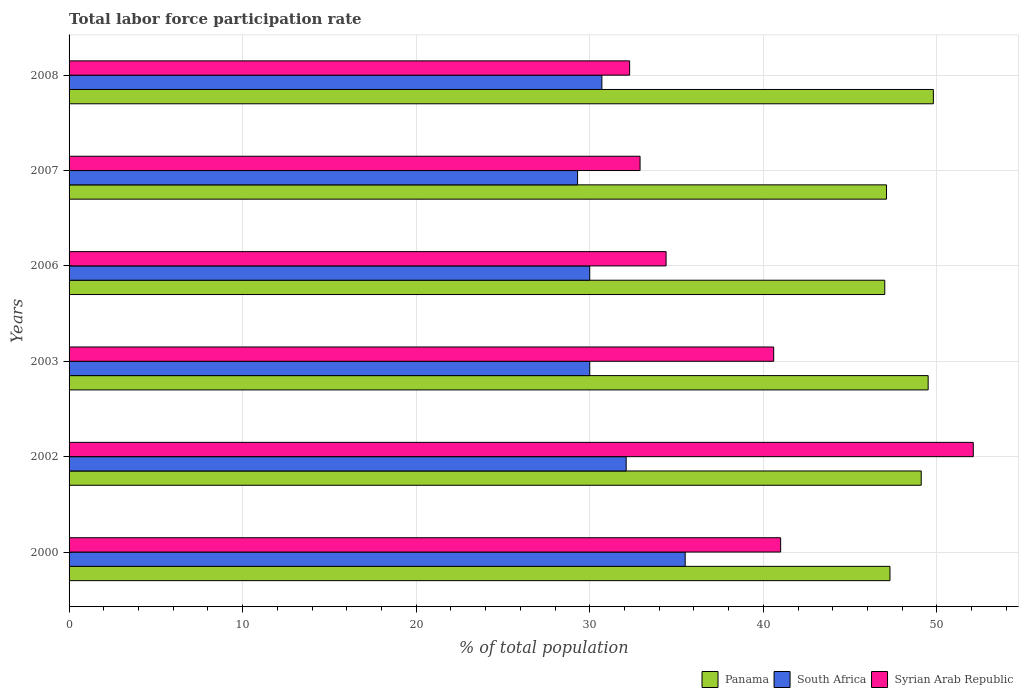How many groups of bars are there?
Keep it short and to the point. 6. Are the number of bars per tick equal to the number of legend labels?
Your answer should be compact. Yes. Are the number of bars on each tick of the Y-axis equal?
Make the answer very short. Yes. How many bars are there on the 2nd tick from the top?
Provide a short and direct response. 3. What is the label of the 3rd group of bars from the top?
Ensure brevity in your answer.  2006. In how many cases, is the number of bars for a given year not equal to the number of legend labels?
Offer a terse response. 0. What is the total labor force participation rate in Syrian Arab Republic in 2003?
Offer a terse response. 40.6. Across all years, what is the maximum total labor force participation rate in South Africa?
Ensure brevity in your answer.  35.5. In which year was the total labor force participation rate in Syrian Arab Republic maximum?
Your answer should be compact. 2002. What is the total total labor force participation rate in South Africa in the graph?
Your answer should be very brief. 187.6. What is the difference between the total labor force participation rate in Panama in 2000 and that in 2007?
Your response must be concise. 0.2. What is the difference between the total labor force participation rate in South Africa in 2008 and the total labor force participation rate in Syrian Arab Republic in 2002?
Your answer should be compact. -21.4. What is the average total labor force participation rate in Syrian Arab Republic per year?
Give a very brief answer. 38.88. In the year 2006, what is the difference between the total labor force participation rate in Syrian Arab Republic and total labor force participation rate in Panama?
Make the answer very short. -12.6. What is the ratio of the total labor force participation rate in South Africa in 2007 to that in 2008?
Your answer should be very brief. 0.95. Is the total labor force participation rate in South Africa in 2006 less than that in 2007?
Your response must be concise. No. Is the difference between the total labor force participation rate in Syrian Arab Republic in 2007 and 2008 greater than the difference between the total labor force participation rate in Panama in 2007 and 2008?
Keep it short and to the point. Yes. What is the difference between the highest and the second highest total labor force participation rate in Syrian Arab Republic?
Your response must be concise. 11.1. What is the difference between the highest and the lowest total labor force participation rate in South Africa?
Provide a succinct answer. 6.2. In how many years, is the total labor force participation rate in Panama greater than the average total labor force participation rate in Panama taken over all years?
Keep it short and to the point. 3. What does the 3rd bar from the top in 2006 represents?
Offer a terse response. Panama. What does the 3rd bar from the bottom in 2008 represents?
Make the answer very short. Syrian Arab Republic. Is it the case that in every year, the sum of the total labor force participation rate in Panama and total labor force participation rate in Syrian Arab Republic is greater than the total labor force participation rate in South Africa?
Keep it short and to the point. Yes. How many bars are there?
Make the answer very short. 18. How many years are there in the graph?
Your response must be concise. 6. What is the difference between two consecutive major ticks on the X-axis?
Ensure brevity in your answer.  10. Are the values on the major ticks of X-axis written in scientific E-notation?
Give a very brief answer. No. Does the graph contain any zero values?
Keep it short and to the point. No. Does the graph contain grids?
Your response must be concise. Yes. Where does the legend appear in the graph?
Provide a succinct answer. Bottom right. How are the legend labels stacked?
Make the answer very short. Horizontal. What is the title of the graph?
Keep it short and to the point. Total labor force participation rate. Does "St. Martin (French part)" appear as one of the legend labels in the graph?
Give a very brief answer. No. What is the label or title of the X-axis?
Offer a very short reply. % of total population. What is the label or title of the Y-axis?
Make the answer very short. Years. What is the % of total population in Panama in 2000?
Offer a terse response. 47.3. What is the % of total population of South Africa in 2000?
Your answer should be very brief. 35.5. What is the % of total population of Syrian Arab Republic in 2000?
Offer a terse response. 41. What is the % of total population of Panama in 2002?
Make the answer very short. 49.1. What is the % of total population in South Africa in 2002?
Offer a terse response. 32.1. What is the % of total population of Syrian Arab Republic in 2002?
Give a very brief answer. 52.1. What is the % of total population in Panama in 2003?
Keep it short and to the point. 49.5. What is the % of total population of Syrian Arab Republic in 2003?
Give a very brief answer. 40.6. What is the % of total population in Panama in 2006?
Your answer should be compact. 47. What is the % of total population in Syrian Arab Republic in 2006?
Your answer should be very brief. 34.4. What is the % of total population in Panama in 2007?
Your answer should be compact. 47.1. What is the % of total population in South Africa in 2007?
Your answer should be compact. 29.3. What is the % of total population of Syrian Arab Republic in 2007?
Provide a short and direct response. 32.9. What is the % of total population in Panama in 2008?
Provide a succinct answer. 49.8. What is the % of total population in South Africa in 2008?
Make the answer very short. 30.7. What is the % of total population of Syrian Arab Republic in 2008?
Make the answer very short. 32.3. Across all years, what is the maximum % of total population in Panama?
Give a very brief answer. 49.8. Across all years, what is the maximum % of total population in South Africa?
Your response must be concise. 35.5. Across all years, what is the maximum % of total population of Syrian Arab Republic?
Your response must be concise. 52.1. Across all years, what is the minimum % of total population of South Africa?
Give a very brief answer. 29.3. Across all years, what is the minimum % of total population in Syrian Arab Republic?
Provide a succinct answer. 32.3. What is the total % of total population of Panama in the graph?
Give a very brief answer. 289.8. What is the total % of total population in South Africa in the graph?
Offer a terse response. 187.6. What is the total % of total population of Syrian Arab Republic in the graph?
Keep it short and to the point. 233.3. What is the difference between the % of total population in Panama in 2000 and that in 2002?
Ensure brevity in your answer.  -1.8. What is the difference between the % of total population in South Africa in 2000 and that in 2002?
Provide a short and direct response. 3.4. What is the difference between the % of total population in Syrian Arab Republic in 2000 and that in 2002?
Keep it short and to the point. -11.1. What is the difference between the % of total population of South Africa in 2000 and that in 2003?
Keep it short and to the point. 5.5. What is the difference between the % of total population of Syrian Arab Republic in 2000 and that in 2003?
Ensure brevity in your answer.  0.4. What is the difference between the % of total population in Panama in 2000 and that in 2006?
Ensure brevity in your answer.  0.3. What is the difference between the % of total population in South Africa in 2000 and that in 2006?
Offer a very short reply. 5.5. What is the difference between the % of total population of Syrian Arab Republic in 2000 and that in 2006?
Your response must be concise. 6.6. What is the difference between the % of total population of Panama in 2000 and that in 2007?
Keep it short and to the point. 0.2. What is the difference between the % of total population of South Africa in 2000 and that in 2007?
Make the answer very short. 6.2. What is the difference between the % of total population of Syrian Arab Republic in 2002 and that in 2003?
Provide a short and direct response. 11.5. What is the difference between the % of total population of Panama in 2002 and that in 2006?
Keep it short and to the point. 2.1. What is the difference between the % of total population in South Africa in 2002 and that in 2006?
Ensure brevity in your answer.  2.1. What is the difference between the % of total population of South Africa in 2002 and that in 2007?
Make the answer very short. 2.8. What is the difference between the % of total population of Panama in 2002 and that in 2008?
Make the answer very short. -0.7. What is the difference between the % of total population of Syrian Arab Republic in 2002 and that in 2008?
Your response must be concise. 19.8. What is the difference between the % of total population of Panama in 2003 and that in 2006?
Offer a terse response. 2.5. What is the difference between the % of total population in Syrian Arab Republic in 2003 and that in 2007?
Ensure brevity in your answer.  7.7. What is the difference between the % of total population of Panama in 2006 and that in 2007?
Make the answer very short. -0.1. What is the difference between the % of total population in South Africa in 2006 and that in 2007?
Your response must be concise. 0.7. What is the difference between the % of total population in Syrian Arab Republic in 2006 and that in 2007?
Your answer should be very brief. 1.5. What is the difference between the % of total population in Panama in 2006 and that in 2008?
Give a very brief answer. -2.8. What is the difference between the % of total population in Syrian Arab Republic in 2006 and that in 2008?
Ensure brevity in your answer.  2.1. What is the difference between the % of total population of South Africa in 2007 and that in 2008?
Your response must be concise. -1.4. What is the difference between the % of total population in Syrian Arab Republic in 2007 and that in 2008?
Give a very brief answer. 0.6. What is the difference between the % of total population in Panama in 2000 and the % of total population in South Africa in 2002?
Your response must be concise. 15.2. What is the difference between the % of total population in South Africa in 2000 and the % of total population in Syrian Arab Republic in 2002?
Your response must be concise. -16.6. What is the difference between the % of total population of South Africa in 2000 and the % of total population of Syrian Arab Republic in 2003?
Your answer should be very brief. -5.1. What is the difference between the % of total population in Panama in 2000 and the % of total population in South Africa in 2006?
Your answer should be compact. 17.3. What is the difference between the % of total population in Panama in 2000 and the % of total population in Syrian Arab Republic in 2007?
Your response must be concise. 14.4. What is the difference between the % of total population of Panama in 2000 and the % of total population of South Africa in 2008?
Make the answer very short. 16.6. What is the difference between the % of total population of Panama in 2000 and the % of total population of Syrian Arab Republic in 2008?
Provide a short and direct response. 15. What is the difference between the % of total population of South Africa in 2002 and the % of total population of Syrian Arab Republic in 2003?
Offer a terse response. -8.5. What is the difference between the % of total population in Panama in 2002 and the % of total population in Syrian Arab Republic in 2006?
Ensure brevity in your answer.  14.7. What is the difference between the % of total population of Panama in 2002 and the % of total population of South Africa in 2007?
Your answer should be compact. 19.8. What is the difference between the % of total population of Panama in 2002 and the % of total population of Syrian Arab Republic in 2007?
Make the answer very short. 16.2. What is the difference between the % of total population in South Africa in 2002 and the % of total population in Syrian Arab Republic in 2007?
Offer a very short reply. -0.8. What is the difference between the % of total population in Panama in 2002 and the % of total population in South Africa in 2008?
Your answer should be compact. 18.4. What is the difference between the % of total population in Panama in 2002 and the % of total population in Syrian Arab Republic in 2008?
Provide a succinct answer. 16.8. What is the difference between the % of total population of Panama in 2003 and the % of total population of Syrian Arab Republic in 2006?
Your response must be concise. 15.1. What is the difference between the % of total population in South Africa in 2003 and the % of total population in Syrian Arab Republic in 2006?
Provide a succinct answer. -4.4. What is the difference between the % of total population of Panama in 2003 and the % of total population of South Africa in 2007?
Keep it short and to the point. 20.2. What is the difference between the % of total population of Panama in 2003 and the % of total population of Syrian Arab Republic in 2007?
Offer a terse response. 16.6. What is the difference between the % of total population of Panama in 2003 and the % of total population of Syrian Arab Republic in 2008?
Make the answer very short. 17.2. What is the difference between the % of total population in South Africa in 2003 and the % of total population in Syrian Arab Republic in 2008?
Provide a succinct answer. -2.3. What is the difference between the % of total population of Panama in 2006 and the % of total population of Syrian Arab Republic in 2007?
Offer a terse response. 14.1. What is the difference between the % of total population in South Africa in 2006 and the % of total population in Syrian Arab Republic in 2007?
Offer a terse response. -2.9. What is the difference between the % of total population of Panama in 2006 and the % of total population of South Africa in 2008?
Keep it short and to the point. 16.3. What is the difference between the % of total population in Panama in 2006 and the % of total population in Syrian Arab Republic in 2008?
Provide a short and direct response. 14.7. What is the difference between the % of total population in South Africa in 2006 and the % of total population in Syrian Arab Republic in 2008?
Keep it short and to the point. -2.3. What is the difference between the % of total population of Panama in 2007 and the % of total population of Syrian Arab Republic in 2008?
Your answer should be compact. 14.8. What is the average % of total population of Panama per year?
Your answer should be very brief. 48.3. What is the average % of total population of South Africa per year?
Your answer should be very brief. 31.27. What is the average % of total population in Syrian Arab Republic per year?
Provide a short and direct response. 38.88. In the year 2000, what is the difference between the % of total population of Panama and % of total population of South Africa?
Offer a terse response. 11.8. In the year 2000, what is the difference between the % of total population of Panama and % of total population of Syrian Arab Republic?
Your response must be concise. 6.3. In the year 2003, what is the difference between the % of total population of Panama and % of total population of South Africa?
Provide a succinct answer. 19.5. In the year 2006, what is the difference between the % of total population of Panama and % of total population of South Africa?
Give a very brief answer. 17. In the year 2006, what is the difference between the % of total population of Panama and % of total population of Syrian Arab Republic?
Offer a very short reply. 12.6. In the year 2006, what is the difference between the % of total population of South Africa and % of total population of Syrian Arab Republic?
Ensure brevity in your answer.  -4.4. In the year 2007, what is the difference between the % of total population in South Africa and % of total population in Syrian Arab Republic?
Offer a terse response. -3.6. In the year 2008, what is the difference between the % of total population in Panama and % of total population in South Africa?
Ensure brevity in your answer.  19.1. What is the ratio of the % of total population in Panama in 2000 to that in 2002?
Provide a succinct answer. 0.96. What is the ratio of the % of total population in South Africa in 2000 to that in 2002?
Provide a succinct answer. 1.11. What is the ratio of the % of total population in Syrian Arab Republic in 2000 to that in 2002?
Offer a terse response. 0.79. What is the ratio of the % of total population in Panama in 2000 to that in 2003?
Your response must be concise. 0.96. What is the ratio of the % of total population of South Africa in 2000 to that in 2003?
Offer a terse response. 1.18. What is the ratio of the % of total population in Syrian Arab Republic in 2000 to that in 2003?
Your response must be concise. 1.01. What is the ratio of the % of total population of Panama in 2000 to that in 2006?
Provide a succinct answer. 1.01. What is the ratio of the % of total population of South Africa in 2000 to that in 2006?
Ensure brevity in your answer.  1.18. What is the ratio of the % of total population in Syrian Arab Republic in 2000 to that in 2006?
Make the answer very short. 1.19. What is the ratio of the % of total population in Panama in 2000 to that in 2007?
Keep it short and to the point. 1. What is the ratio of the % of total population of South Africa in 2000 to that in 2007?
Your response must be concise. 1.21. What is the ratio of the % of total population of Syrian Arab Republic in 2000 to that in 2007?
Offer a very short reply. 1.25. What is the ratio of the % of total population of Panama in 2000 to that in 2008?
Your response must be concise. 0.95. What is the ratio of the % of total population of South Africa in 2000 to that in 2008?
Provide a succinct answer. 1.16. What is the ratio of the % of total population of Syrian Arab Republic in 2000 to that in 2008?
Provide a succinct answer. 1.27. What is the ratio of the % of total population of Panama in 2002 to that in 2003?
Your response must be concise. 0.99. What is the ratio of the % of total population of South Africa in 2002 to that in 2003?
Offer a terse response. 1.07. What is the ratio of the % of total population in Syrian Arab Republic in 2002 to that in 2003?
Give a very brief answer. 1.28. What is the ratio of the % of total population in Panama in 2002 to that in 2006?
Offer a very short reply. 1.04. What is the ratio of the % of total population of South Africa in 2002 to that in 2006?
Offer a very short reply. 1.07. What is the ratio of the % of total population in Syrian Arab Republic in 2002 to that in 2006?
Provide a short and direct response. 1.51. What is the ratio of the % of total population of Panama in 2002 to that in 2007?
Ensure brevity in your answer.  1.04. What is the ratio of the % of total population in South Africa in 2002 to that in 2007?
Your answer should be very brief. 1.1. What is the ratio of the % of total population in Syrian Arab Republic in 2002 to that in 2007?
Your answer should be compact. 1.58. What is the ratio of the % of total population in Panama in 2002 to that in 2008?
Your answer should be compact. 0.99. What is the ratio of the % of total population in South Africa in 2002 to that in 2008?
Offer a terse response. 1.05. What is the ratio of the % of total population of Syrian Arab Republic in 2002 to that in 2008?
Your answer should be very brief. 1.61. What is the ratio of the % of total population of Panama in 2003 to that in 2006?
Your answer should be compact. 1.05. What is the ratio of the % of total population in South Africa in 2003 to that in 2006?
Keep it short and to the point. 1. What is the ratio of the % of total population of Syrian Arab Republic in 2003 to that in 2006?
Give a very brief answer. 1.18. What is the ratio of the % of total population of Panama in 2003 to that in 2007?
Offer a terse response. 1.05. What is the ratio of the % of total population in South Africa in 2003 to that in 2007?
Provide a short and direct response. 1.02. What is the ratio of the % of total population of Syrian Arab Republic in 2003 to that in 2007?
Provide a short and direct response. 1.23. What is the ratio of the % of total population in Panama in 2003 to that in 2008?
Your answer should be compact. 0.99. What is the ratio of the % of total population in South Africa in 2003 to that in 2008?
Provide a succinct answer. 0.98. What is the ratio of the % of total population of Syrian Arab Republic in 2003 to that in 2008?
Give a very brief answer. 1.26. What is the ratio of the % of total population of Panama in 2006 to that in 2007?
Provide a succinct answer. 1. What is the ratio of the % of total population in South Africa in 2006 to that in 2007?
Ensure brevity in your answer.  1.02. What is the ratio of the % of total population in Syrian Arab Republic in 2006 to that in 2007?
Provide a short and direct response. 1.05. What is the ratio of the % of total population of Panama in 2006 to that in 2008?
Offer a terse response. 0.94. What is the ratio of the % of total population in South Africa in 2006 to that in 2008?
Your answer should be very brief. 0.98. What is the ratio of the % of total population of Syrian Arab Republic in 2006 to that in 2008?
Ensure brevity in your answer.  1.06. What is the ratio of the % of total population in Panama in 2007 to that in 2008?
Give a very brief answer. 0.95. What is the ratio of the % of total population of South Africa in 2007 to that in 2008?
Offer a terse response. 0.95. What is the ratio of the % of total population of Syrian Arab Republic in 2007 to that in 2008?
Your answer should be very brief. 1.02. What is the difference between the highest and the second highest % of total population of South Africa?
Provide a short and direct response. 3.4. What is the difference between the highest and the lowest % of total population in Panama?
Your answer should be very brief. 2.8. What is the difference between the highest and the lowest % of total population of Syrian Arab Republic?
Your response must be concise. 19.8. 